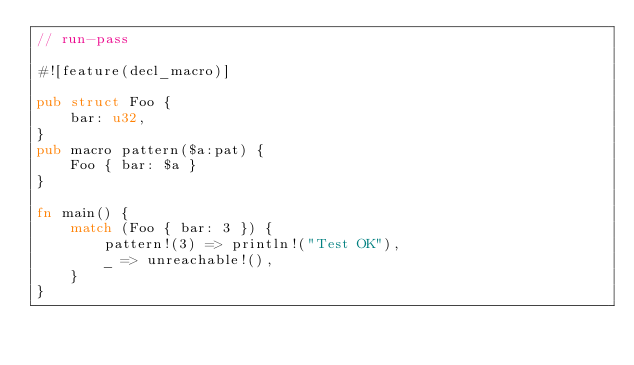Convert code to text. <code><loc_0><loc_0><loc_500><loc_500><_Rust_>// run-pass

#![feature(decl_macro)]

pub struct Foo {
    bar: u32,
}
pub macro pattern($a:pat) {
    Foo { bar: $a }
}

fn main() {
    match (Foo { bar: 3 }) {
        pattern!(3) => println!("Test OK"),
        _ => unreachable!(),
    }
}
</code> 